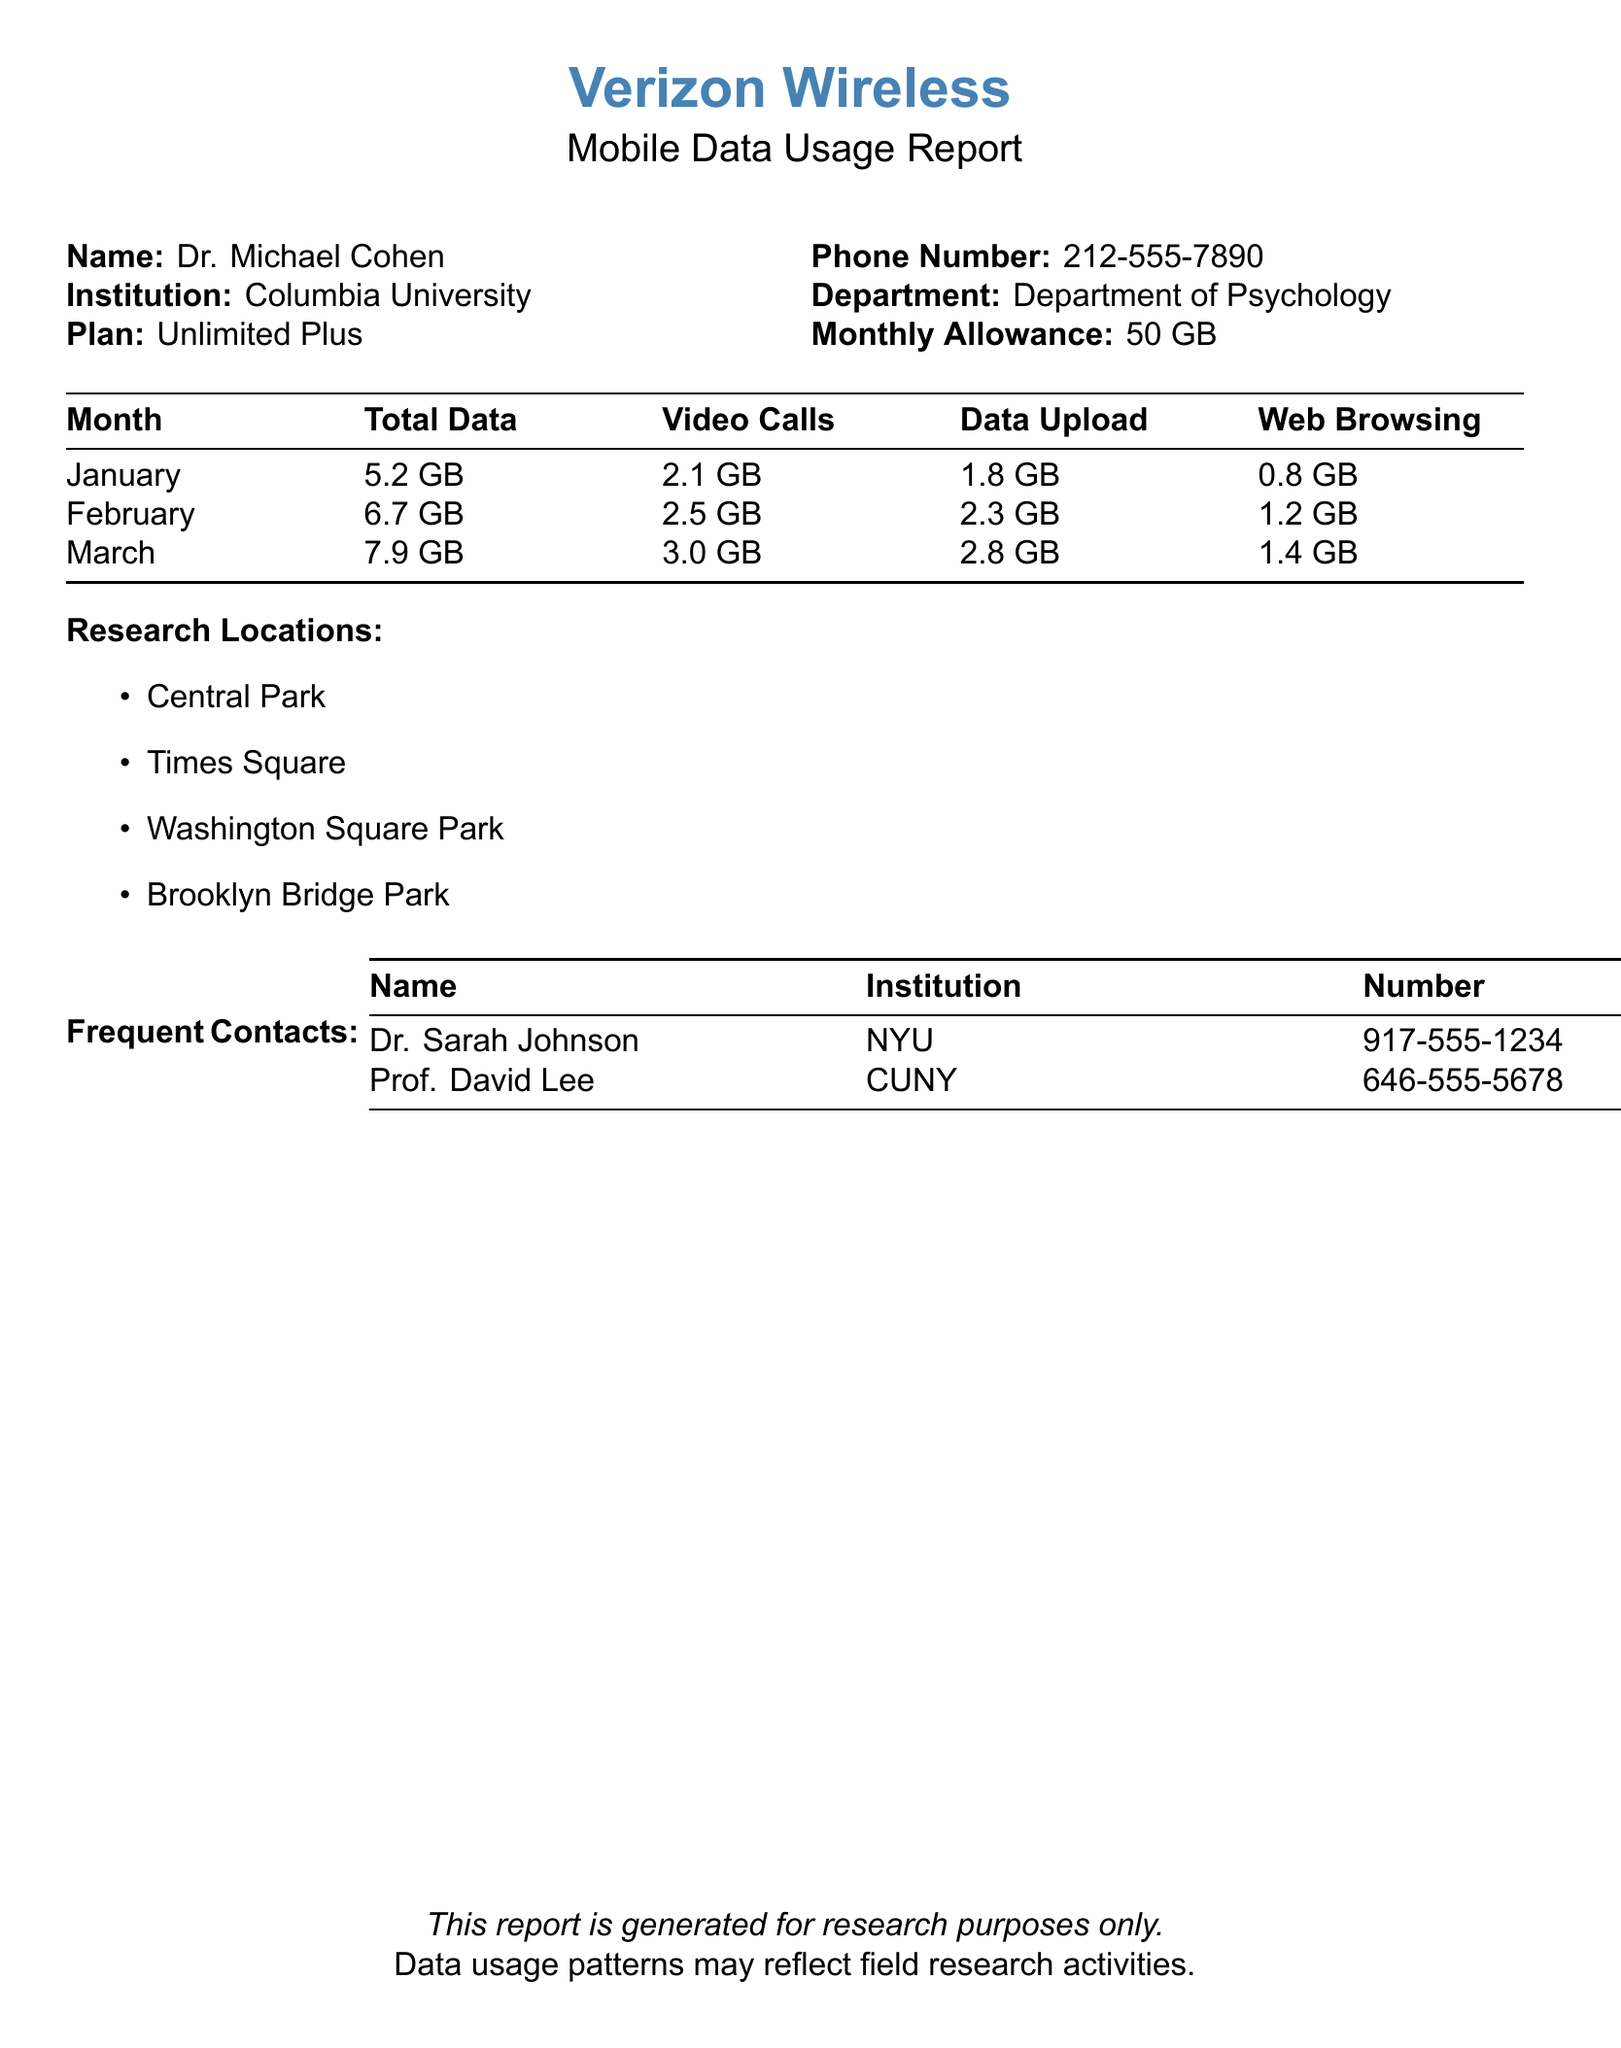What is the monthly allowance? The monthly allowance is specified in the document as part of the mobile plan.
Answer: 50 GB What was the total data usage in March? The total data usage for March is presented in the table of data usage for different months.
Answer: 7.9 GB How much data was used for video calls in February? The document includes specific usage data for video calls for each month.
Answer: 2.5 GB What locations were included in the research? The document lists the locations where the research was conducted.
Answer: Central Park, Times Square, Washington Square Park, Brooklyn Bridge Park Who is a frequent contact with the number 646-555-5678? The document provides a list of frequent contacts with their names and institutions.
Answer: Prof. David Lee What is the total data used for web browsing in January? Data usage for web browsing is listed in the monthly breakdown.
Answer: 0.8 GB Which month had the highest data upload? The data upload information is provided in the monthly data usage table.
Answer: March How many frequent contacts are listed in the document? The document states the number of frequent contacts explicitly.
Answer: 2 